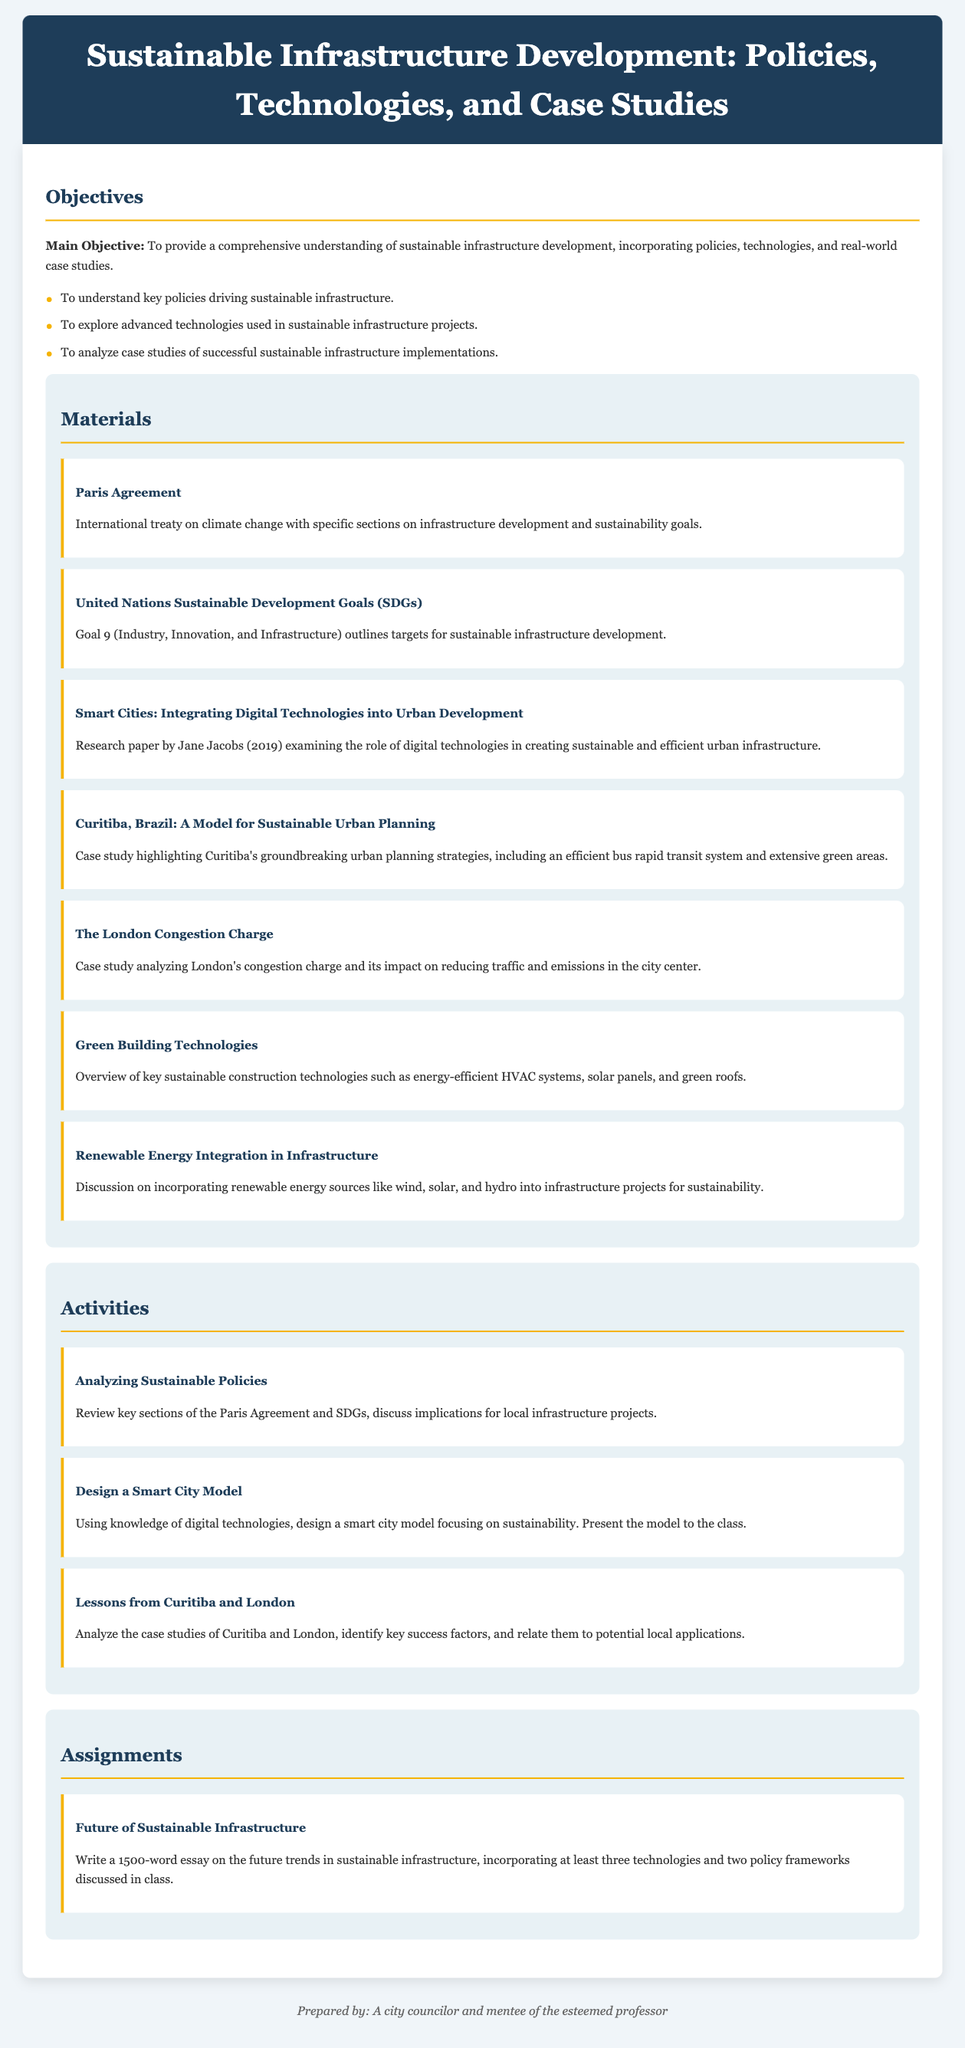What is the main objective of the lesson plan? The main objective is to provide a comprehensive understanding of sustainable infrastructure development, incorporating policies, technologies, and real-world case studies.
Answer: Comprehensive understanding of sustainable infrastructure development How many key policies are mentioned in the objectives? The objectives list three specific goals to understand key policies, technologies, and case studies.
Answer: Three What is Goal 9 of the United Nations Sustainable Development Goals? Goal 9 (Industry, Innovation, and Infrastructure) outlines targets for sustainable infrastructure development.
Answer: Industry, Innovation, and Infrastructure Who authored the research paper on integrating digital technologies into urban development? The research paper titled "Smart Cities: Integrating Digital Technologies into Urban Development" was authored by Jane Jacobs.
Answer: Jane Jacobs What is one of the activities planned for this lesson? An activity involves analyzing the case studies of Curitiba and London to identify key success factors.
Answer: Analyzing sustainable policies How many words should the essay assignment contain? The assignment specifies that the essay should be 1500 words long.
Answer: 1500 words What type of building technologies are discussed in the materials section? The materials section includes an overview of key sustainable construction technologies.
Answer: Green Building Technologies Which city is highlighted as a model for sustainable urban planning? The case study highlights Curitiba, Brazil as a model for sustainable urban planning.
Answer: Curitiba, Brazil 